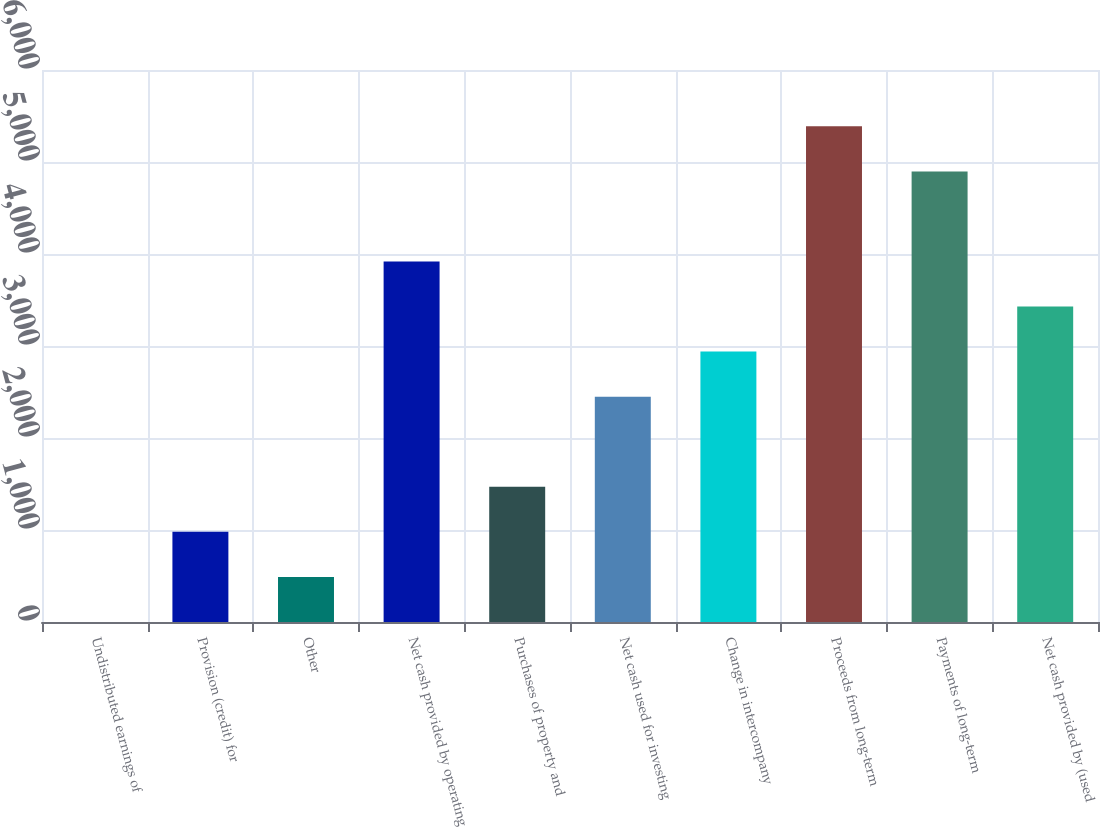Convert chart to OTSL. <chart><loc_0><loc_0><loc_500><loc_500><bar_chart><fcel>Undistributed earnings of<fcel>Provision (credit) for<fcel>Other<fcel>Net cash provided by operating<fcel>Purchases of property and<fcel>Net cash used for investing<fcel>Change in intercompany<fcel>Proceeds from long-term<fcel>Payments of long-term<fcel>Net cash provided by (used<nl><fcel>0.5<fcel>980<fcel>490.25<fcel>3918.5<fcel>1469.75<fcel>2449.25<fcel>2939<fcel>5387.75<fcel>4898<fcel>3428.75<nl></chart> 